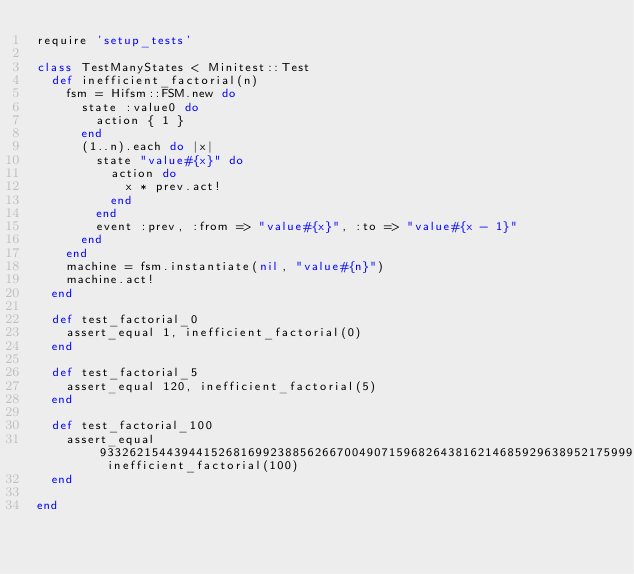Convert code to text. <code><loc_0><loc_0><loc_500><loc_500><_Ruby_>require 'setup_tests'

class TestManyStates < Minitest::Test
  def inefficient_factorial(n)
    fsm = Hifsm::FSM.new do
      state :value0 do
        action { 1 }
      end
      (1..n).each do |x|
        state "value#{x}" do
          action do
            x * prev.act!
          end
        end
        event :prev, :from => "value#{x}", :to => "value#{x - 1}"
      end
    end
    machine = fsm.instantiate(nil, "value#{n}")
    machine.act!
  end

  def test_factorial_0
    assert_equal 1, inefficient_factorial(0)
  end

  def test_factorial_5
    assert_equal 120, inefficient_factorial(5)
  end

  def test_factorial_100
    assert_equal 93326215443944152681699238856266700490715968264381621468592963895217599993229915608941463976156518286253697920827223758251185210916864000000000000000000000000, inefficient_factorial(100)
  end

end
</code> 